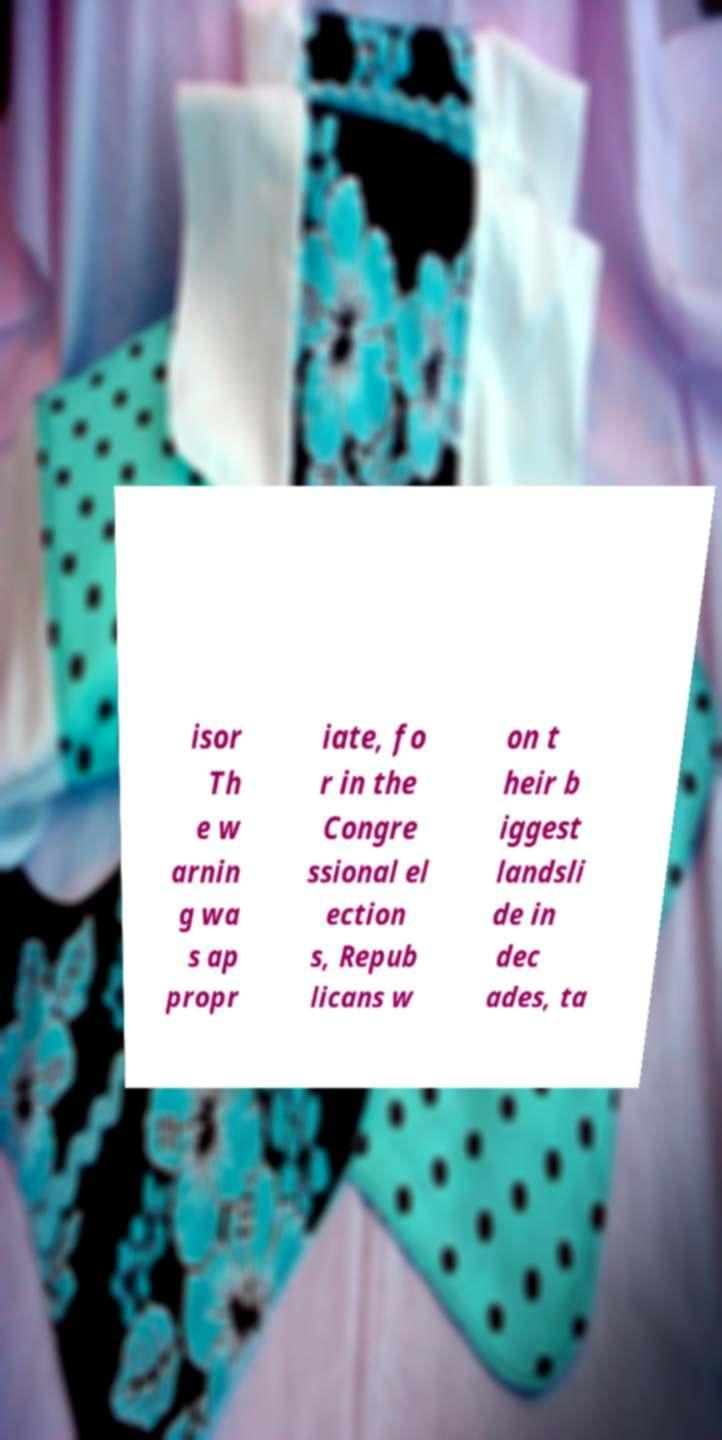Please identify and transcribe the text found in this image. isor Th e w arnin g wa s ap propr iate, fo r in the Congre ssional el ection s, Repub licans w on t heir b iggest landsli de in dec ades, ta 